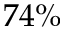<formula> <loc_0><loc_0><loc_500><loc_500>7 4 \%</formula> 